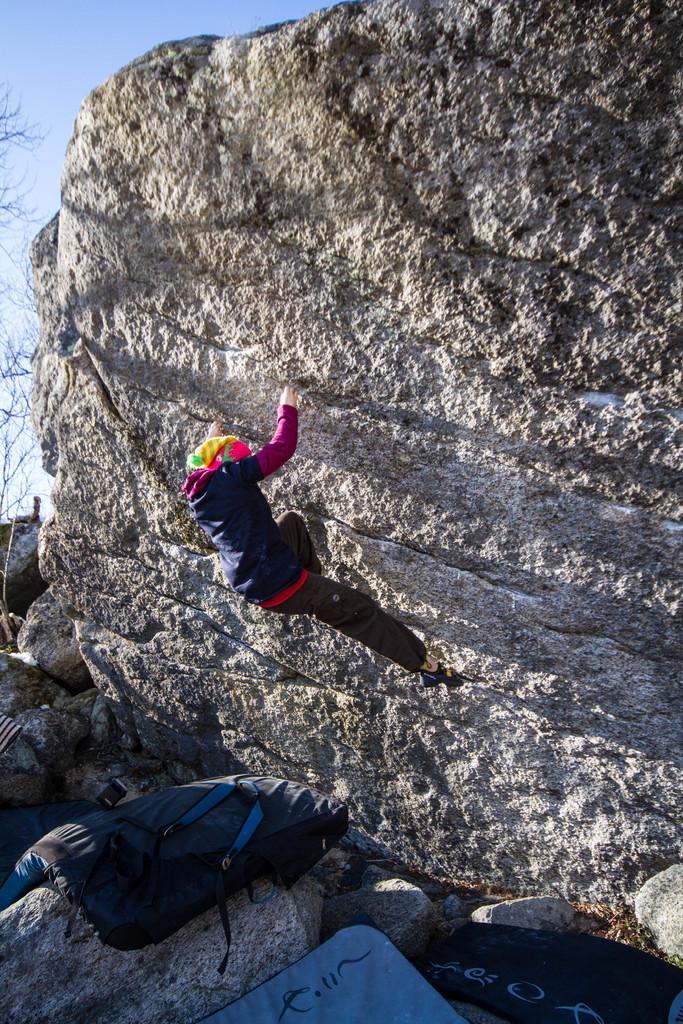Please provide a concise description of this image. In the image there is a person climbing a rock. At the bottom of the image there are bags on the rocks. On the left side of the image there are branches and also there is a sky. 